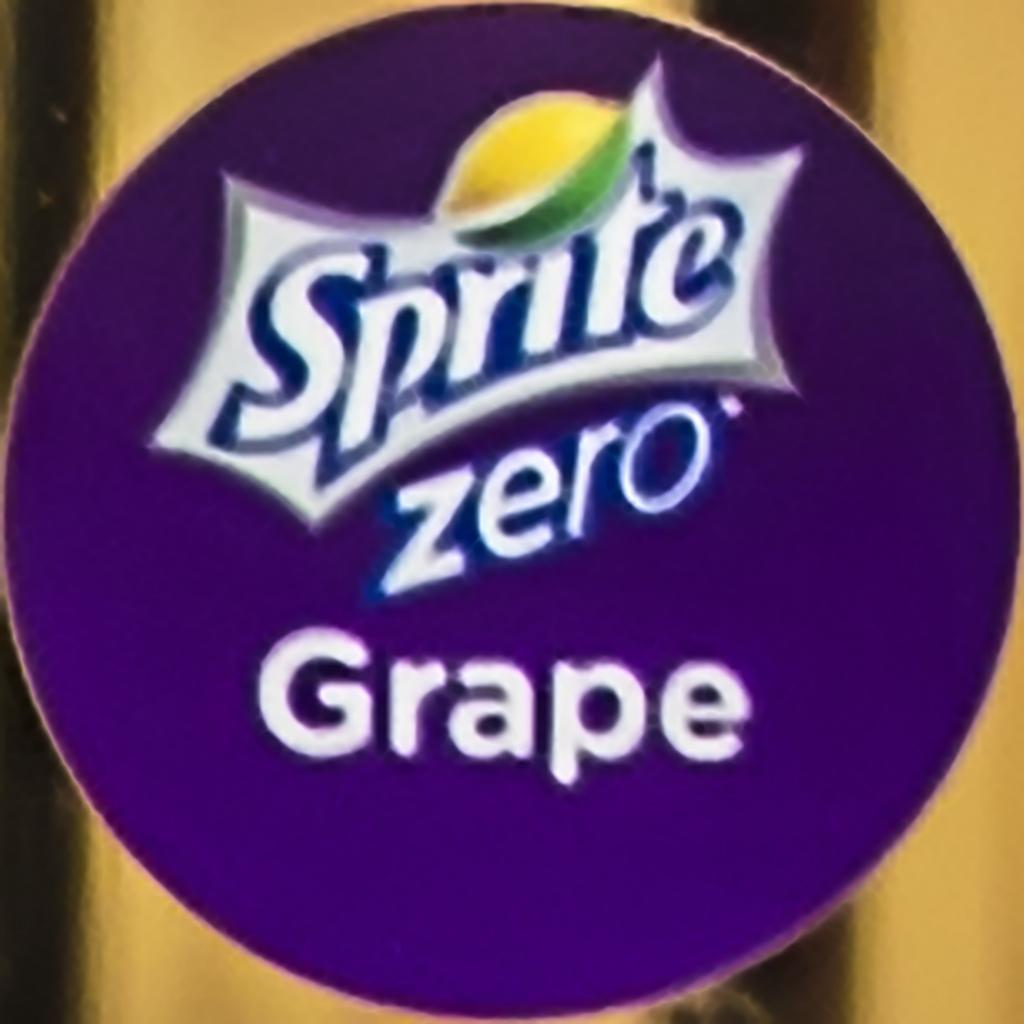What shape is the main subject in the image? There is a purple color circle in the image. What is inside the circle in the image? There is some text within the circle. What type of bread can be seen in the image? There is no bread present in the image. Is there a dock visible in the image? There is no dock present in the image. Can you see a kitten playing within the circle in the image? There is no kitten present in the image. 